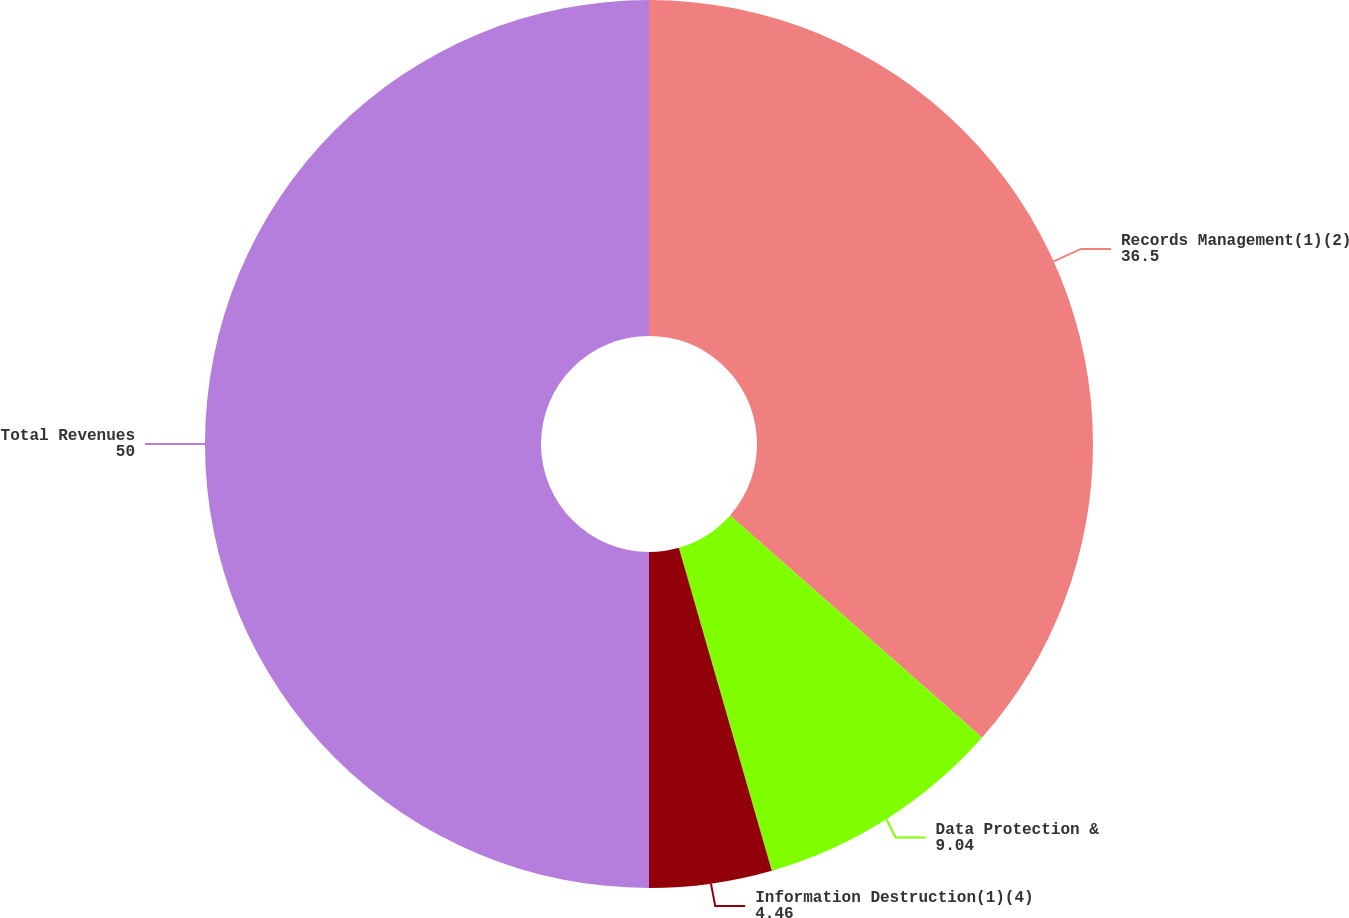Convert chart to OTSL. <chart><loc_0><loc_0><loc_500><loc_500><pie_chart><fcel>Records Management(1)(2)<fcel>Data Protection &<fcel>Information Destruction(1)(4)<fcel>Total Revenues<nl><fcel>36.5%<fcel>9.04%<fcel>4.46%<fcel>50.0%<nl></chart> 